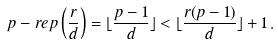Convert formula to latex. <formula><loc_0><loc_0><loc_500><loc_500>p - r e p \left ( \frac { r } { d } \right ) = \lfloor \frac { p - 1 } { d } \rfloor < \lfloor \frac { r ( p - 1 ) } { d } \rfloor + 1 \, .</formula> 